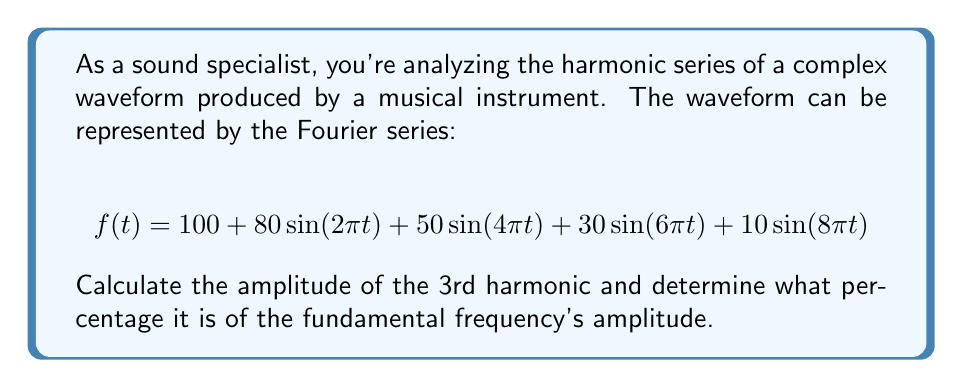Could you help me with this problem? To solve this problem, we need to follow these steps:

1. Identify the fundamental frequency and its amplitude:
   The fundamental frequency is represented by the term with the lowest frequency, which is $80\sin(2\pi t)$. Its amplitude is 80.

2. Identify the 3rd harmonic:
   The 3rd harmonic has a frequency that is 3 times the fundamental frequency. In this Fourier series, it's represented by the term $30\sin(6\pi t)$.

3. Determine the amplitude of the 3rd harmonic:
   The amplitude of the 3rd harmonic is 30.

4. Calculate the percentage:
   To find what percentage the 3rd harmonic's amplitude is of the fundamental frequency's amplitude, we use the formula:

   $$\text{Percentage} = \frac{\text{Amplitude of 3rd harmonic}}{\text{Amplitude of fundamental}} \times 100\%$$

   $$= \frac{30}{80} \times 100\% = 0.375 \times 100\% = 37.5\%$$

Therefore, the amplitude of the 3rd harmonic is 37.5% of the fundamental frequency's amplitude.
Answer: The amplitude of the 3rd harmonic is 30, which is 37.5% of the fundamental frequency's amplitude. 